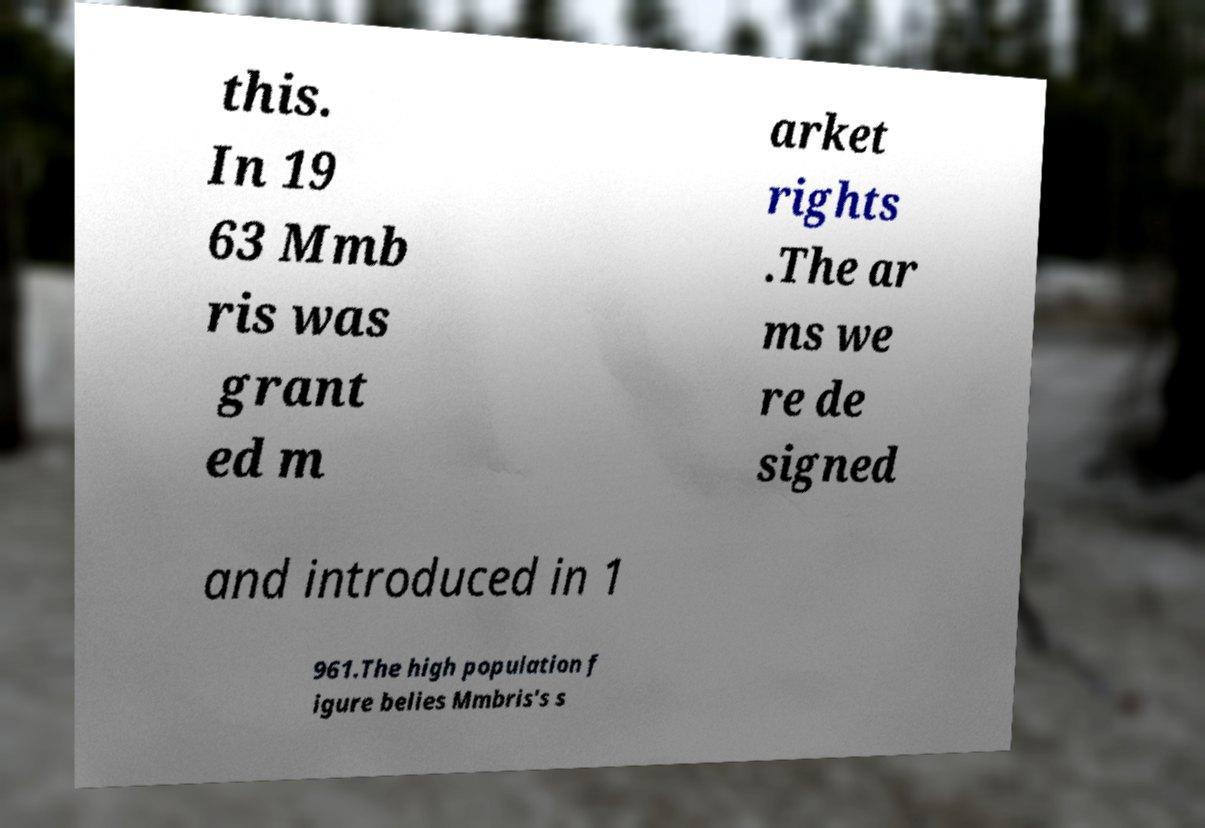Could you extract and type out the text from this image? this. In 19 63 Mmb ris was grant ed m arket rights .The ar ms we re de signed and introduced in 1 961.The high population f igure belies Mmbris's s 